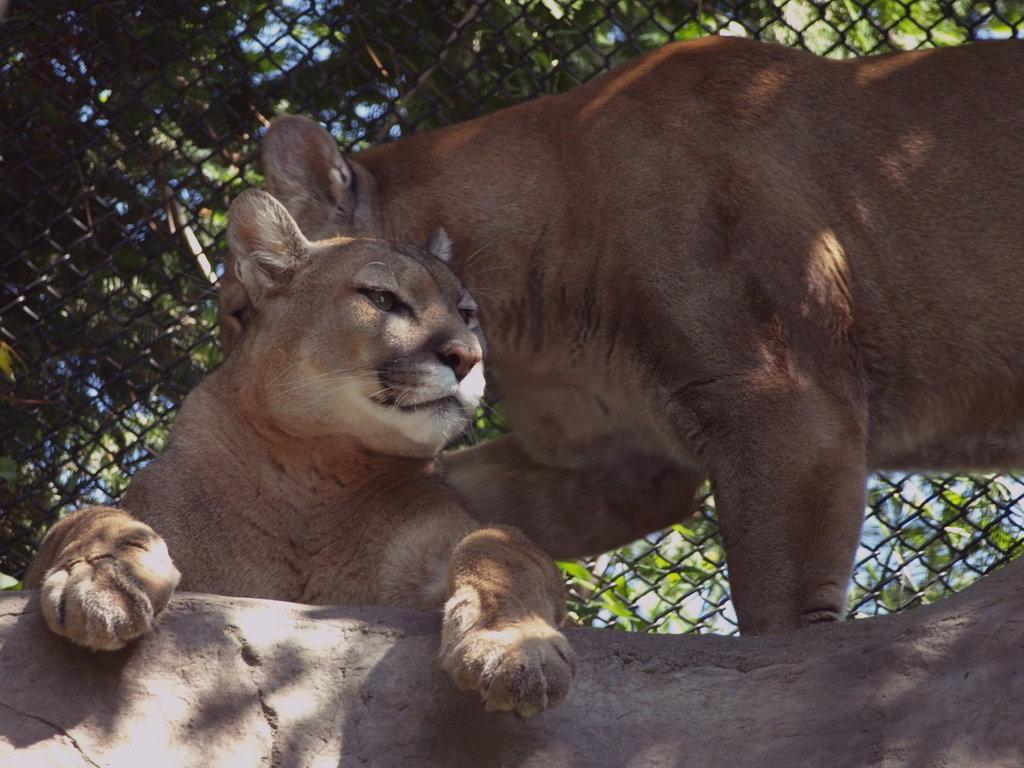What animals are present in the image? There are two cougars in the image. Where are the cougars located? The cougars are on a stone. What can be seen in the background of the image? There are trees, plants, and the sky visible in the background of the image. What type of barrier is visible in the image? There is fencing visible in the image. What type of soup is being served on the sofa in the image? There is no sofa or soup present in the image; it features two cougars on a stone with a background of trees, plants, and the sky. 